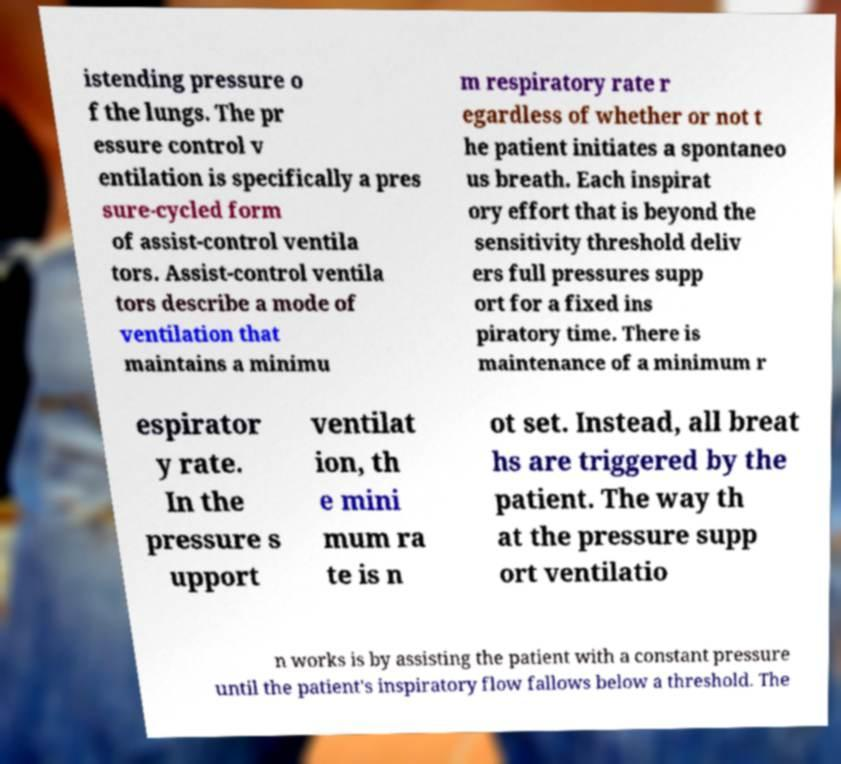Could you extract and type out the text from this image? istending pressure o f the lungs. The pr essure control v entilation is specifically a pres sure-cycled form of assist-control ventila tors. Assist-control ventila tors describe a mode of ventilation that maintains a minimu m respiratory rate r egardless of whether or not t he patient initiates a spontaneo us breath. Each inspirat ory effort that is beyond the sensitivity threshold deliv ers full pressures supp ort for a fixed ins piratory time. There is maintenance of a minimum r espirator y rate. In the pressure s upport ventilat ion, th e mini mum ra te is n ot set. Instead, all breat hs are triggered by the patient. The way th at the pressure supp ort ventilatio n works is by assisting the patient with a constant pressure until the patient's inspiratory flow fallows below a threshold. The 